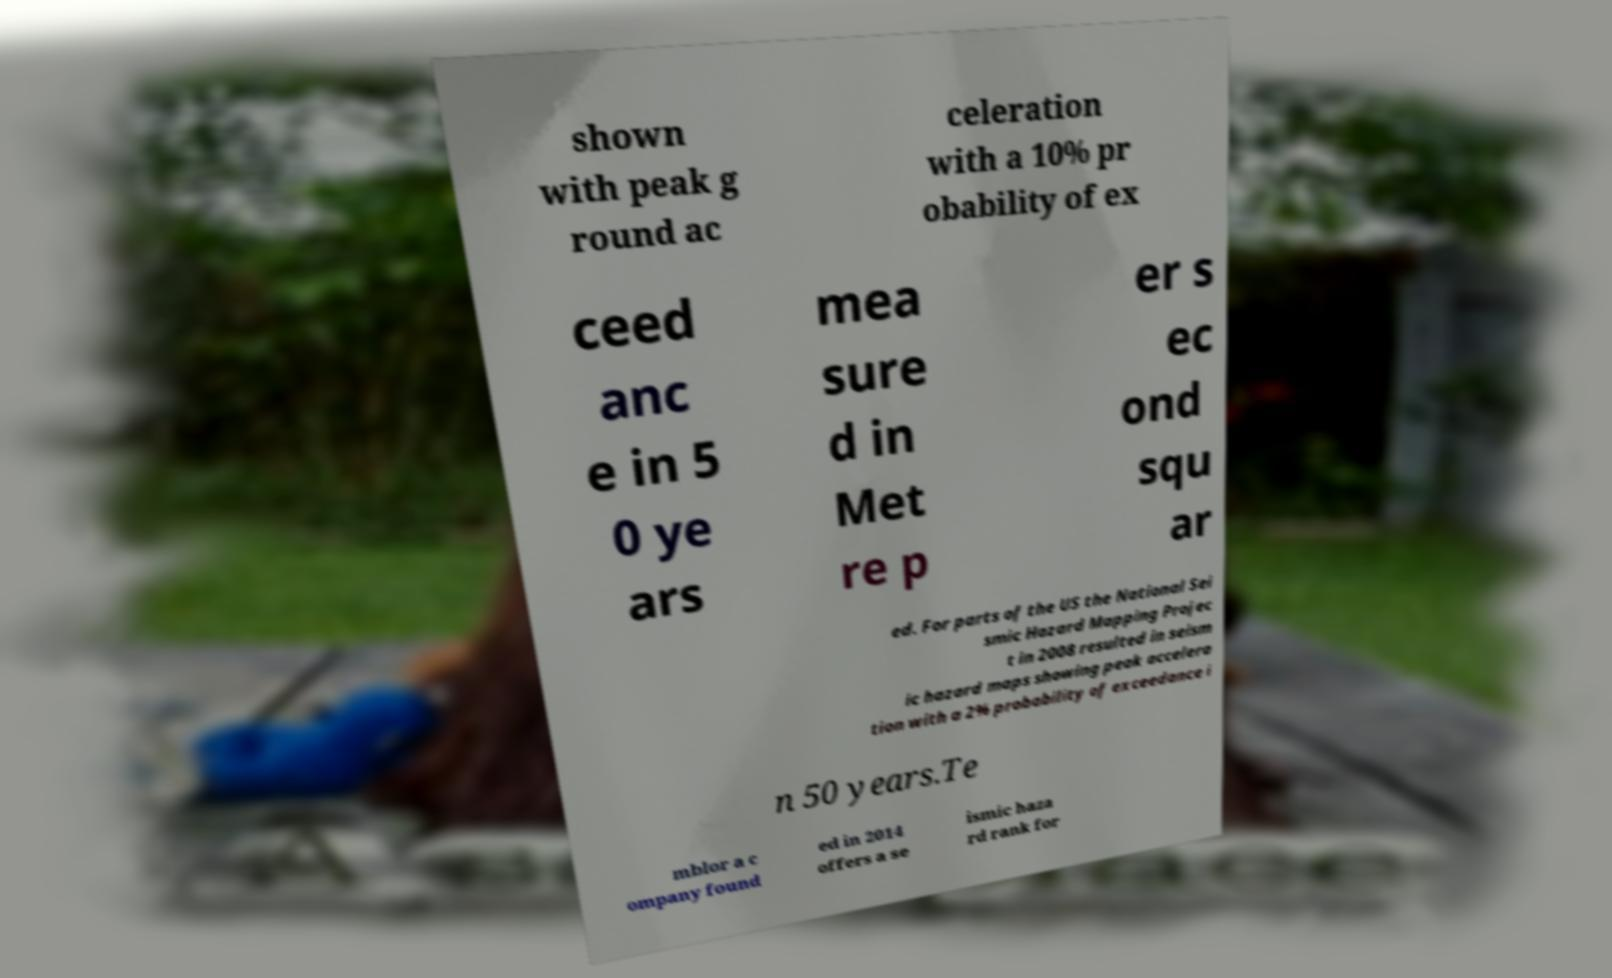I need the written content from this picture converted into text. Can you do that? shown with peak g round ac celeration with a 10% pr obability of ex ceed anc e in 5 0 ye ars mea sure d in Met re p er s ec ond squ ar ed. For parts of the US the National Sei smic Hazard Mapping Projec t in 2008 resulted in seism ic hazard maps showing peak accelera tion with a 2% probability of exceedance i n 50 years.Te mblor a c ompany found ed in 2014 offers a se ismic haza rd rank for 